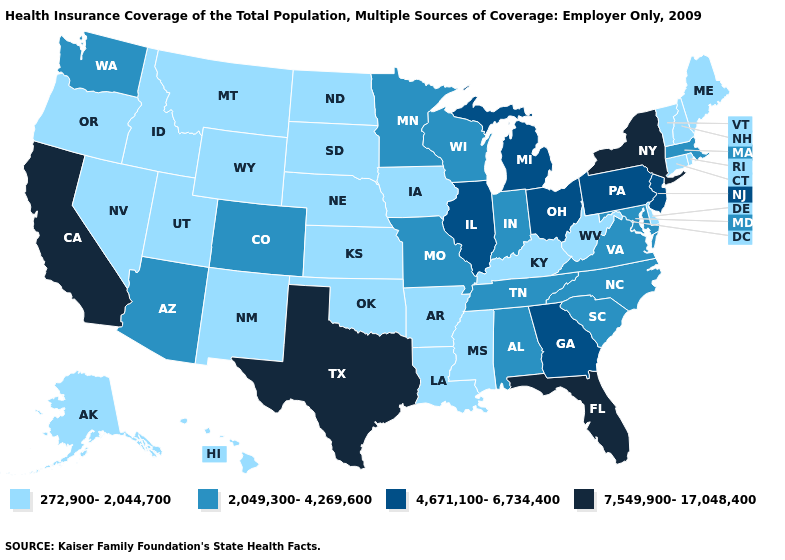Among the states that border West Virginia , does Kentucky have the lowest value?
Write a very short answer. Yes. Among the states that border Kentucky , does Missouri have the lowest value?
Write a very short answer. No. Does the first symbol in the legend represent the smallest category?
Be succinct. Yes. Which states have the lowest value in the South?
Write a very short answer. Arkansas, Delaware, Kentucky, Louisiana, Mississippi, Oklahoma, West Virginia. Which states have the lowest value in the USA?
Answer briefly. Alaska, Arkansas, Connecticut, Delaware, Hawaii, Idaho, Iowa, Kansas, Kentucky, Louisiana, Maine, Mississippi, Montana, Nebraska, Nevada, New Hampshire, New Mexico, North Dakota, Oklahoma, Oregon, Rhode Island, South Dakota, Utah, Vermont, West Virginia, Wyoming. Among the states that border Nevada , does Utah have the highest value?
Quick response, please. No. Does Louisiana have the same value as Ohio?
Be succinct. No. Does Rhode Island have the lowest value in the Northeast?
Answer briefly. Yes. What is the value of Texas?
Short answer required. 7,549,900-17,048,400. What is the value of Florida?
Answer briefly. 7,549,900-17,048,400. Does the first symbol in the legend represent the smallest category?
Quick response, please. Yes. Name the states that have a value in the range 272,900-2,044,700?
Short answer required. Alaska, Arkansas, Connecticut, Delaware, Hawaii, Idaho, Iowa, Kansas, Kentucky, Louisiana, Maine, Mississippi, Montana, Nebraska, Nevada, New Hampshire, New Mexico, North Dakota, Oklahoma, Oregon, Rhode Island, South Dakota, Utah, Vermont, West Virginia, Wyoming. Among the states that border Massachusetts , which have the highest value?
Keep it brief. New York. What is the lowest value in the USA?
Concise answer only. 272,900-2,044,700. Name the states that have a value in the range 2,049,300-4,269,600?
Short answer required. Alabama, Arizona, Colorado, Indiana, Maryland, Massachusetts, Minnesota, Missouri, North Carolina, South Carolina, Tennessee, Virginia, Washington, Wisconsin. 